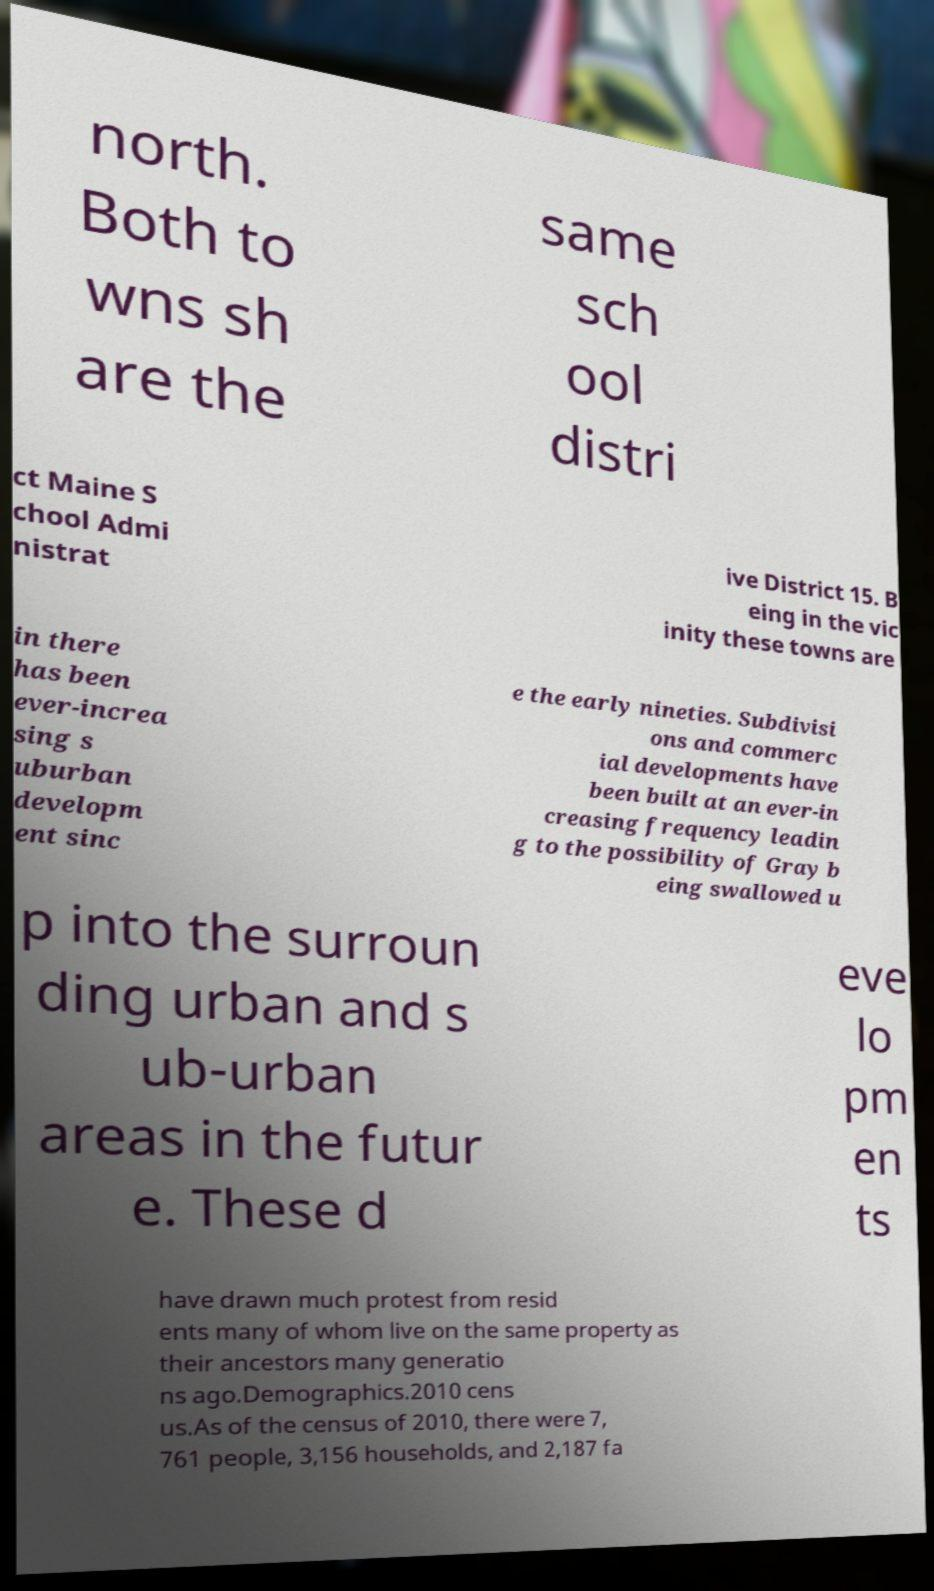Could you assist in decoding the text presented in this image and type it out clearly? north. Both to wns sh are the same sch ool distri ct Maine S chool Admi nistrat ive District 15. B eing in the vic inity these towns are in there has been ever-increa sing s uburban developm ent sinc e the early nineties. Subdivisi ons and commerc ial developments have been built at an ever-in creasing frequency leadin g to the possibility of Gray b eing swallowed u p into the surroun ding urban and s ub-urban areas in the futur e. These d eve lo pm en ts have drawn much protest from resid ents many of whom live on the same property as their ancestors many generatio ns ago.Demographics.2010 cens us.As of the census of 2010, there were 7, 761 people, 3,156 households, and 2,187 fa 